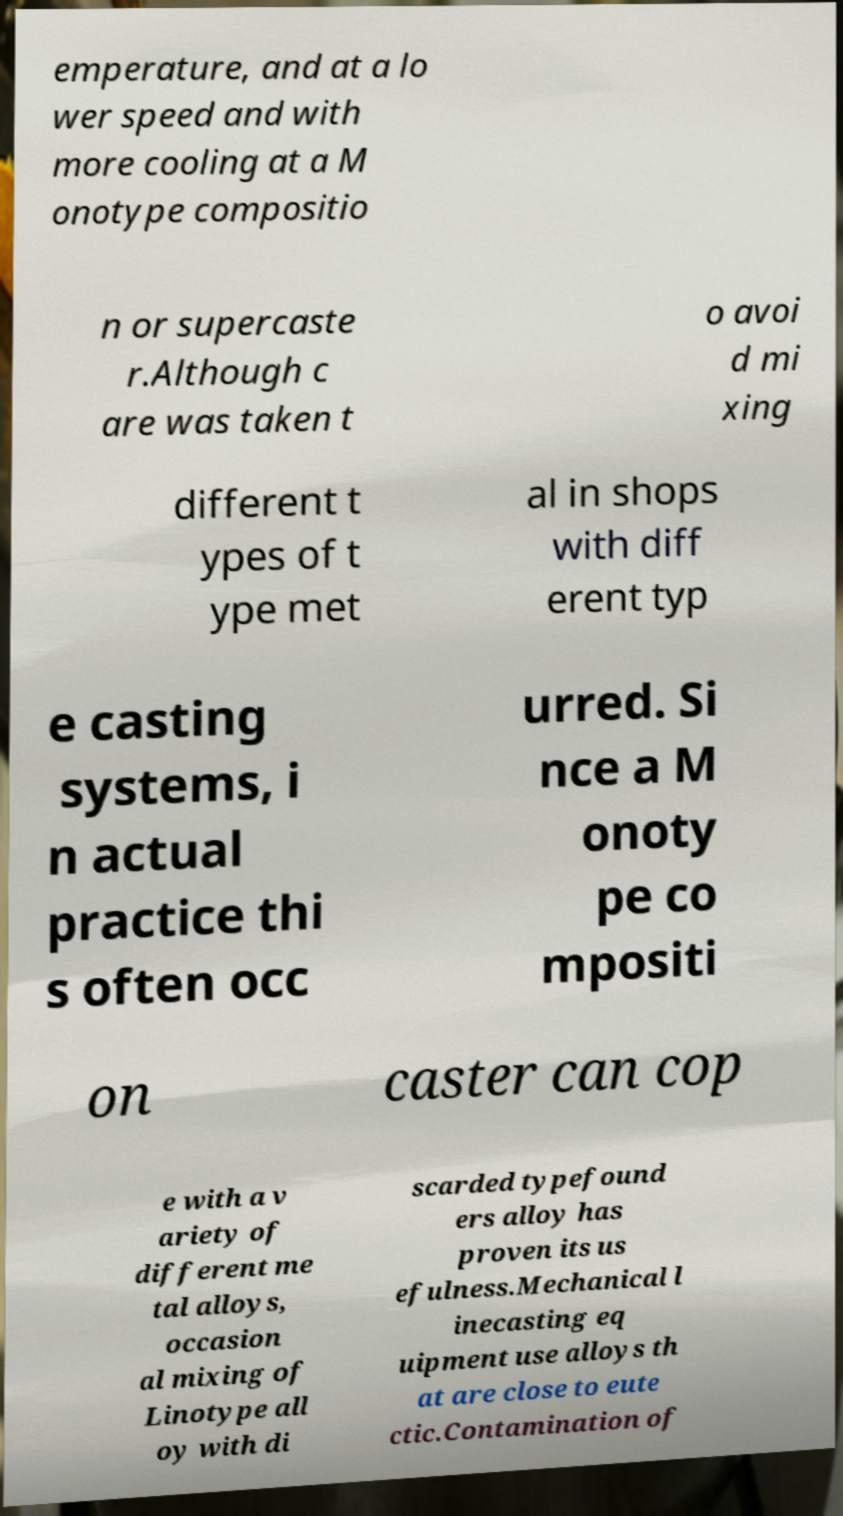There's text embedded in this image that I need extracted. Can you transcribe it verbatim? emperature, and at a lo wer speed and with more cooling at a M onotype compositio n or supercaste r.Although c are was taken t o avoi d mi xing different t ypes of t ype met al in shops with diff erent typ e casting systems, i n actual practice thi s often occ urred. Si nce a M onoty pe co mpositi on caster can cop e with a v ariety of different me tal alloys, occasion al mixing of Linotype all oy with di scarded typefound ers alloy has proven its us efulness.Mechanical l inecasting eq uipment use alloys th at are close to eute ctic.Contamination of 